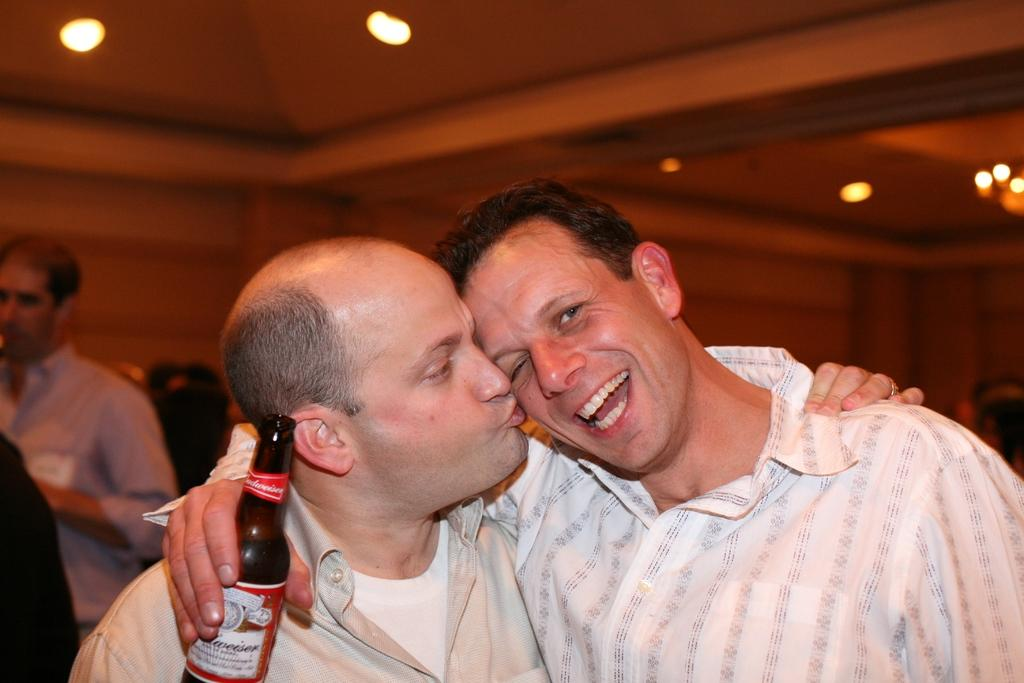How many people are in the image? There are two persons in the image. What is the expression of one of the persons? One person is smiling. What is the smiling person holding? The smiling person is holding a bottle. Can you describe the lighting in the image? There is a light in the background of the image. What type of scarf is the person wearing in the image? There is no mention of a scarf in the image. 